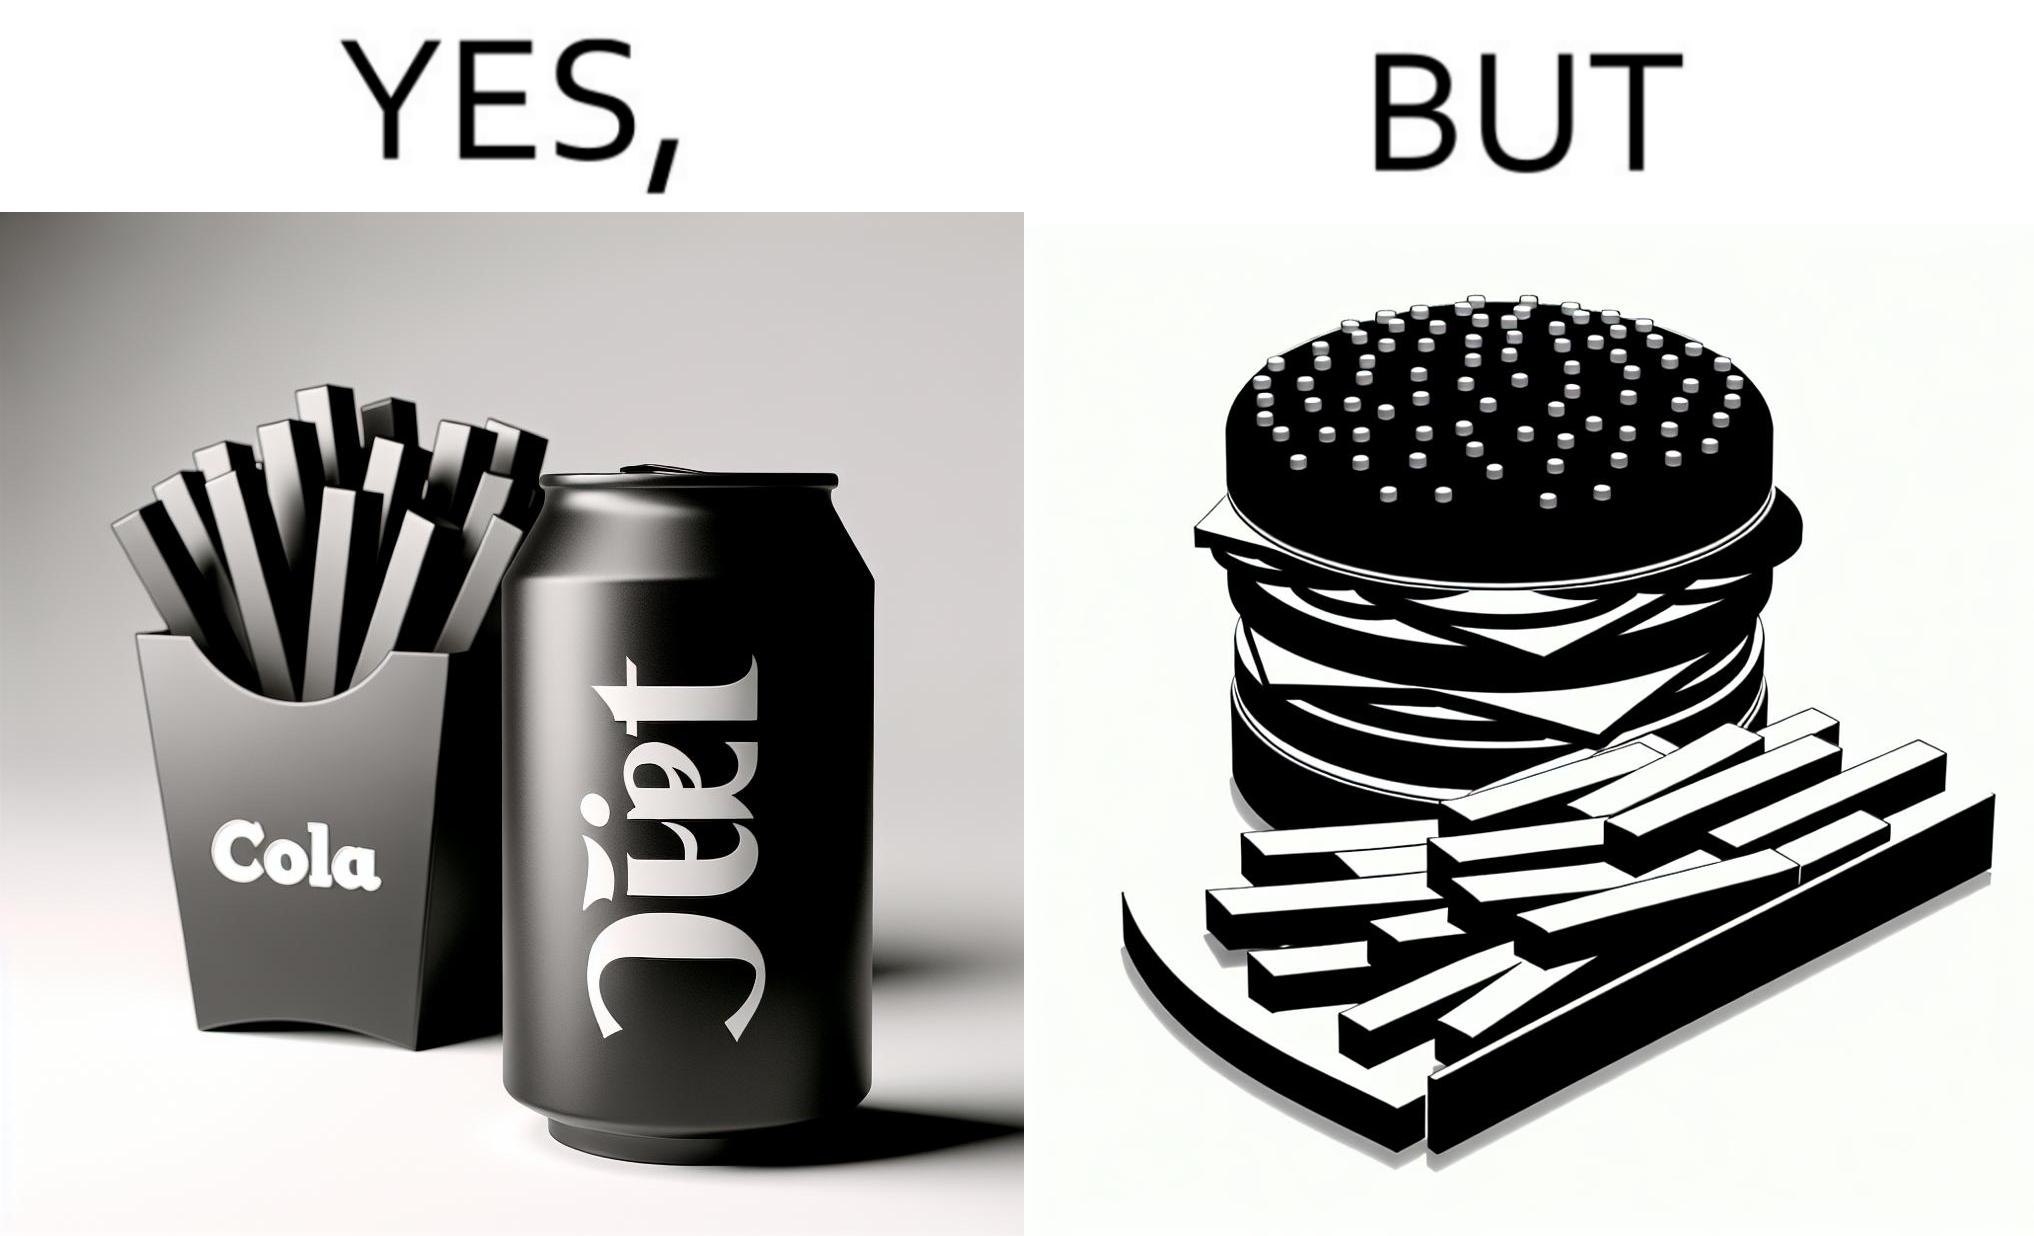Compare the left and right sides of this image. In the left part of the image: a cold drink can, named by diet cola, with french fries at the back In the right part of the image: a huge size burger with french fries 